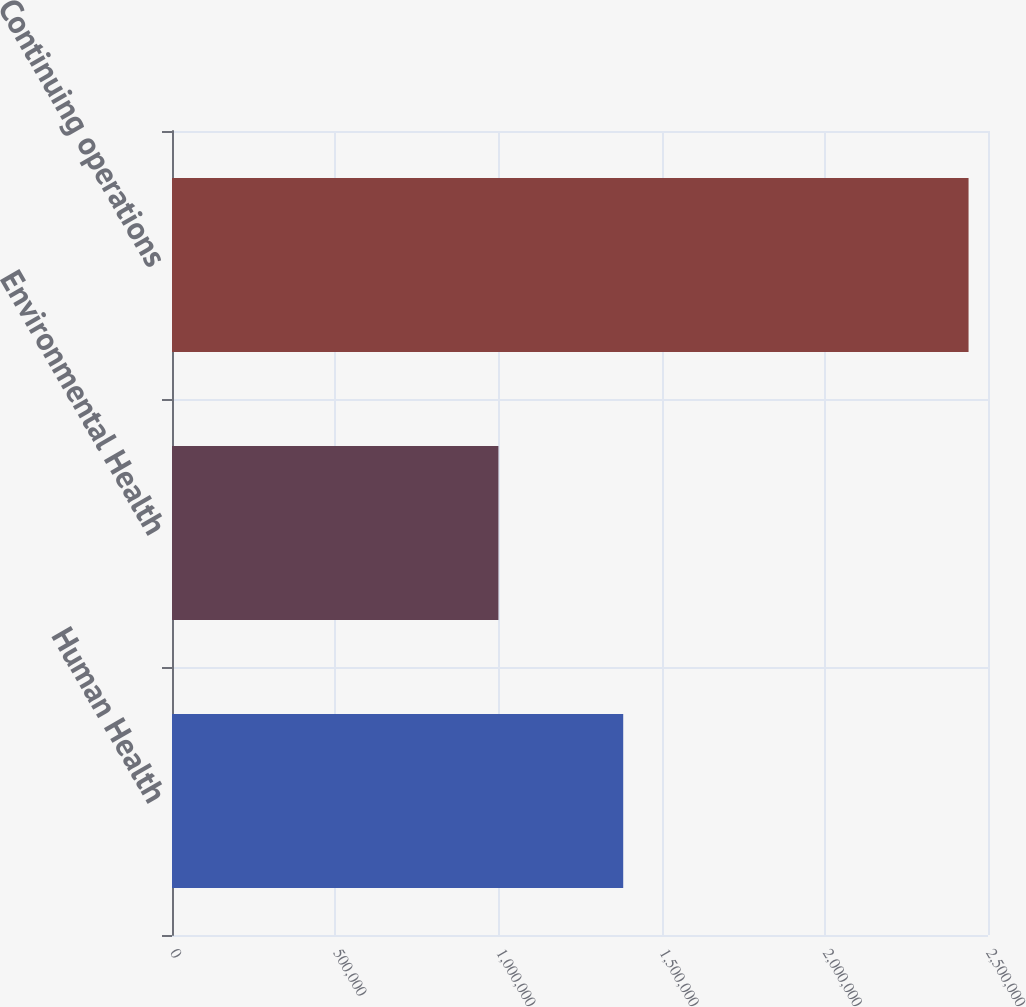Convert chart to OTSL. <chart><loc_0><loc_0><loc_500><loc_500><bar_chart><fcel>Human Health<fcel>Environmental Health<fcel>Continuing operations<nl><fcel>1.38241e+06<fcel>1.00005e+06<fcel>2.44044e+06<nl></chart> 